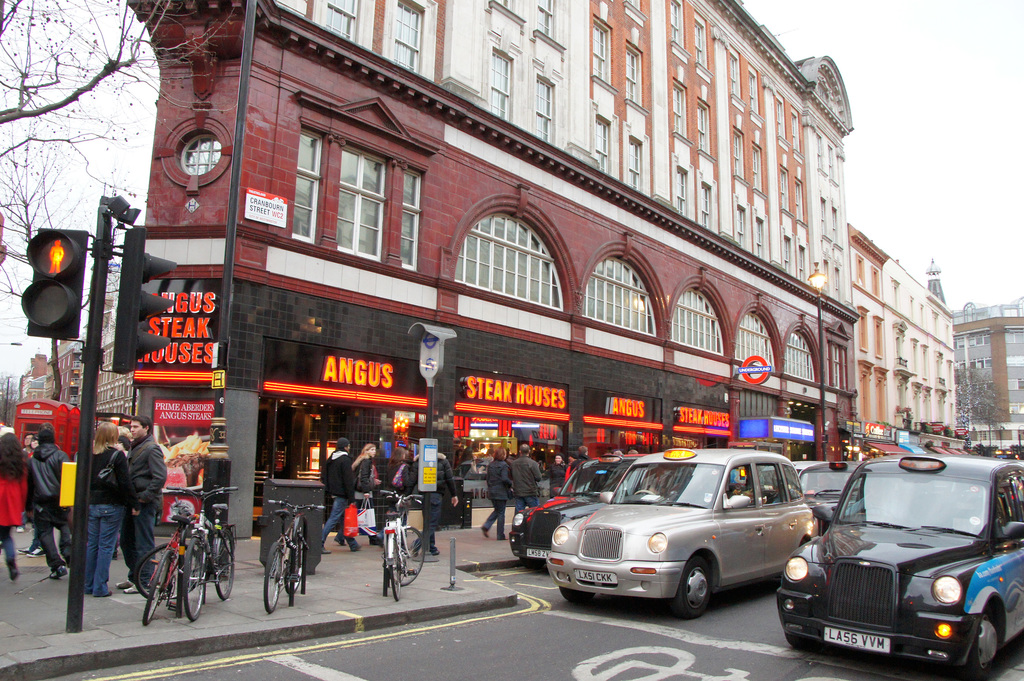Provide a one-sentence caption for the provided image. The image captures a bustling street scene outside the Angus Steak Houses in a busy urban area, featuring pedestrians, cyclists, and iconic black taxis under the glow of neon signs, framed by a mix of historical and contemporary architecture. 